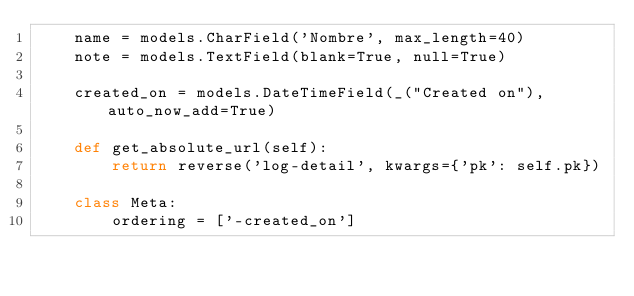<code> <loc_0><loc_0><loc_500><loc_500><_Python_>    name = models.CharField('Nombre', max_length=40)
    note = models.TextField(blank=True, null=True)

    created_on = models.DateTimeField(_("Created on"), auto_now_add=True)

    def get_absolute_url(self):
        return reverse('log-detail', kwargs={'pk': self.pk})

    class Meta:
        ordering = ['-created_on']
</code> 